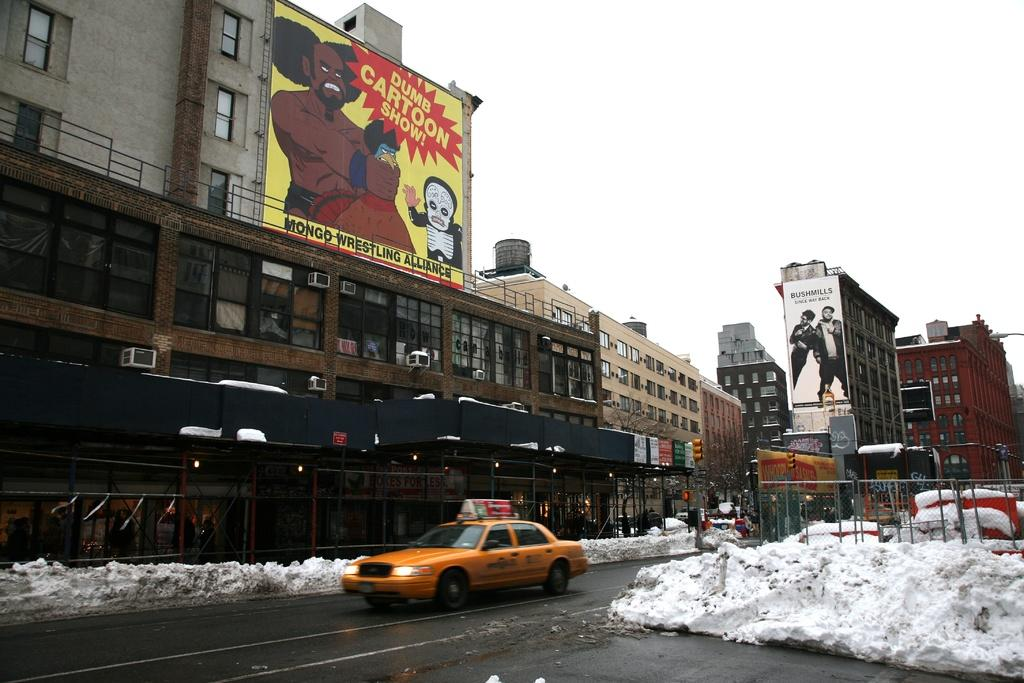<image>
Render a clear and concise summary of the photo. Dumb Cartoon Show banner ad on the top of a building with a taxi cab on the road with snow. 